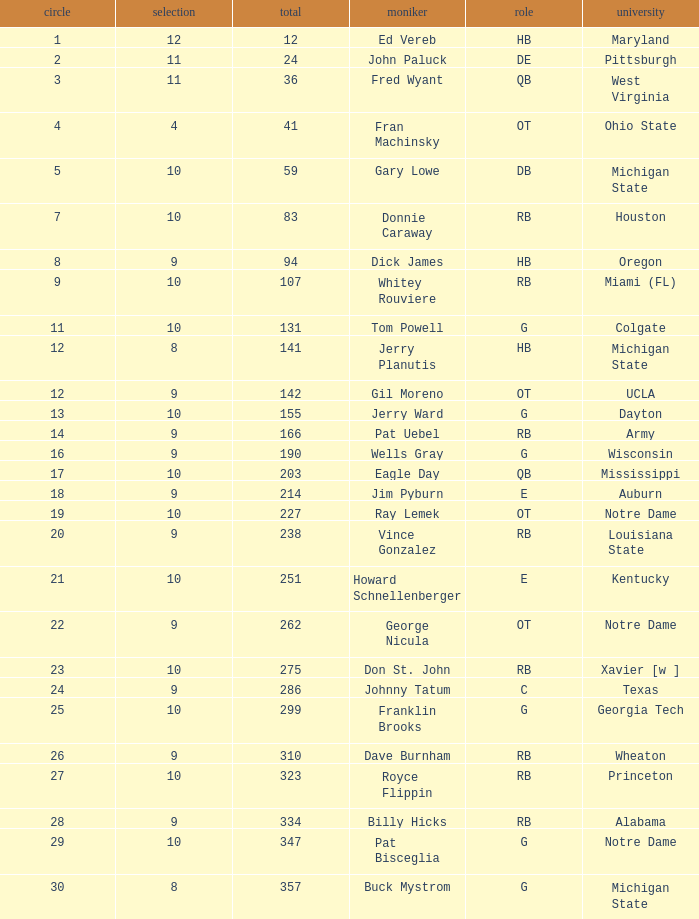What is the highest round number for donnie caraway? 7.0. 